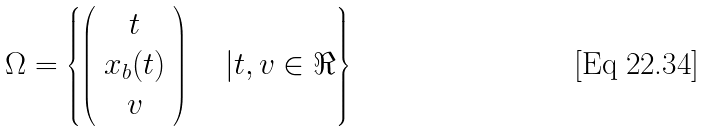<formula> <loc_0><loc_0><loc_500><loc_500>\Omega = \left \{ \left ( \begin{array} { c } t \\ x _ { b } ( t ) \\ v \end{array} \right ) \quad | t , v \in \Re \right \}</formula> 